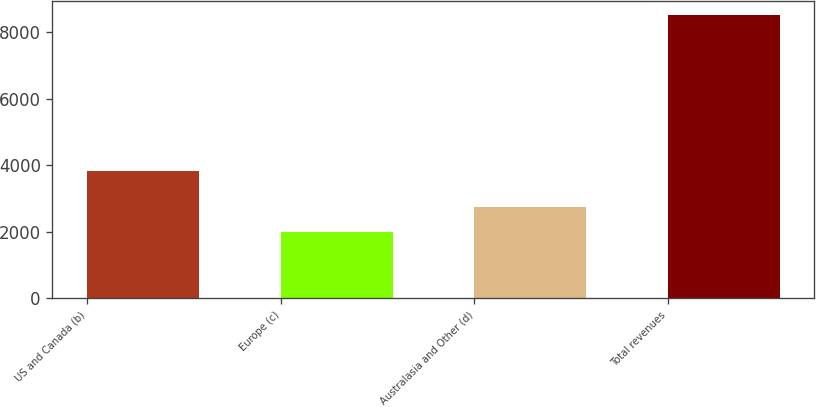Convert chart to OTSL. <chart><loc_0><loc_0><loc_500><loc_500><bar_chart><fcel>US and Canada (b)<fcel>Europe (c)<fcel>Australasia and Other (d)<fcel>Total revenues<nl><fcel>3808<fcel>1982<fcel>2734<fcel>8524<nl></chart> 